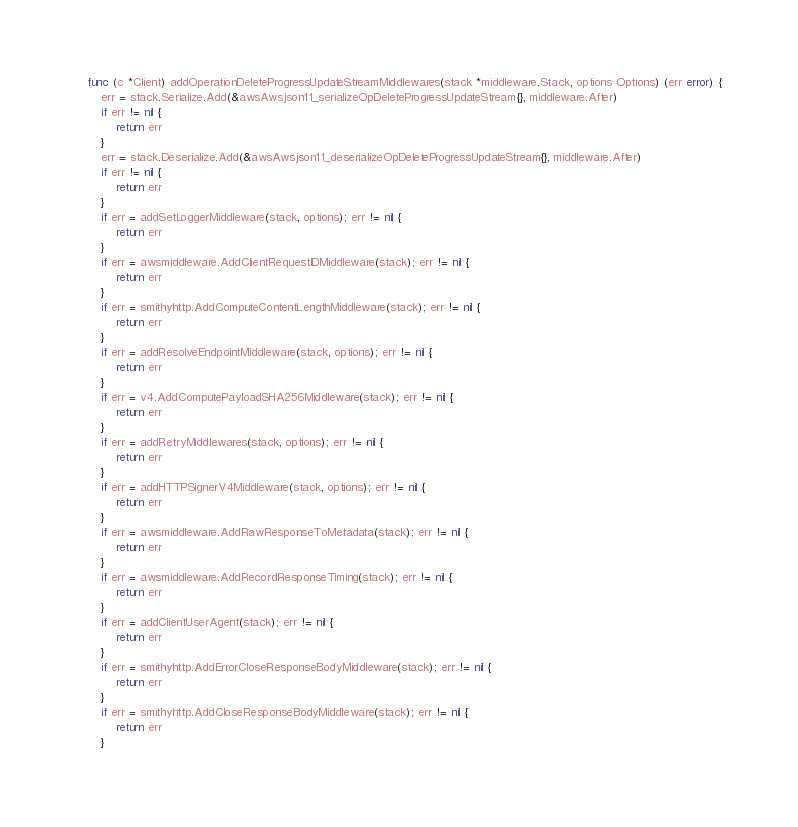Convert code to text. <code><loc_0><loc_0><loc_500><loc_500><_Go_>func (c *Client) addOperationDeleteProgressUpdateStreamMiddlewares(stack *middleware.Stack, options Options) (err error) {
	err = stack.Serialize.Add(&awsAwsjson11_serializeOpDeleteProgressUpdateStream{}, middleware.After)
	if err != nil {
		return err
	}
	err = stack.Deserialize.Add(&awsAwsjson11_deserializeOpDeleteProgressUpdateStream{}, middleware.After)
	if err != nil {
		return err
	}
	if err = addSetLoggerMiddleware(stack, options); err != nil {
		return err
	}
	if err = awsmiddleware.AddClientRequestIDMiddleware(stack); err != nil {
		return err
	}
	if err = smithyhttp.AddComputeContentLengthMiddleware(stack); err != nil {
		return err
	}
	if err = addResolveEndpointMiddleware(stack, options); err != nil {
		return err
	}
	if err = v4.AddComputePayloadSHA256Middleware(stack); err != nil {
		return err
	}
	if err = addRetryMiddlewares(stack, options); err != nil {
		return err
	}
	if err = addHTTPSignerV4Middleware(stack, options); err != nil {
		return err
	}
	if err = awsmiddleware.AddRawResponseToMetadata(stack); err != nil {
		return err
	}
	if err = awsmiddleware.AddRecordResponseTiming(stack); err != nil {
		return err
	}
	if err = addClientUserAgent(stack); err != nil {
		return err
	}
	if err = smithyhttp.AddErrorCloseResponseBodyMiddleware(stack); err != nil {
		return err
	}
	if err = smithyhttp.AddCloseResponseBodyMiddleware(stack); err != nil {
		return err
	}</code> 